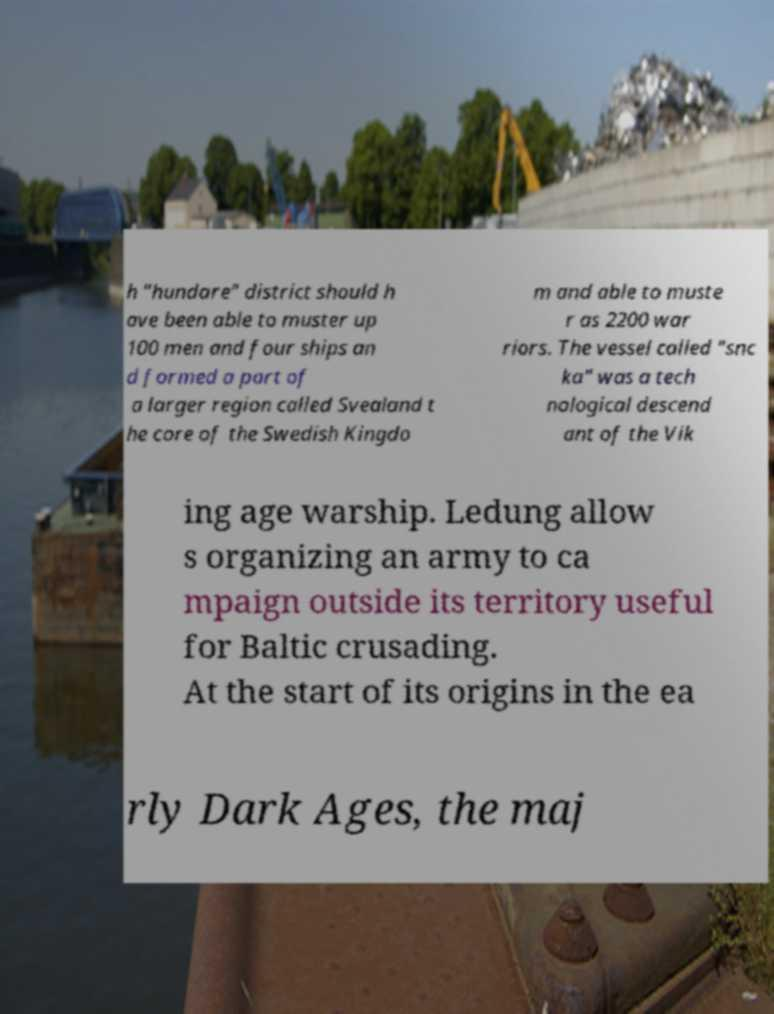Can you read and provide the text displayed in the image?This photo seems to have some interesting text. Can you extract and type it out for me? h "hundare" district should h ave been able to muster up 100 men and four ships an d formed a part of a larger region called Svealand t he core of the Swedish Kingdo m and able to muste r as 2200 war riors. The vessel called "snc ka" was a tech nological descend ant of the Vik ing age warship. Ledung allow s organizing an army to ca mpaign outside its territory useful for Baltic crusading. At the start of its origins in the ea rly Dark Ages, the maj 